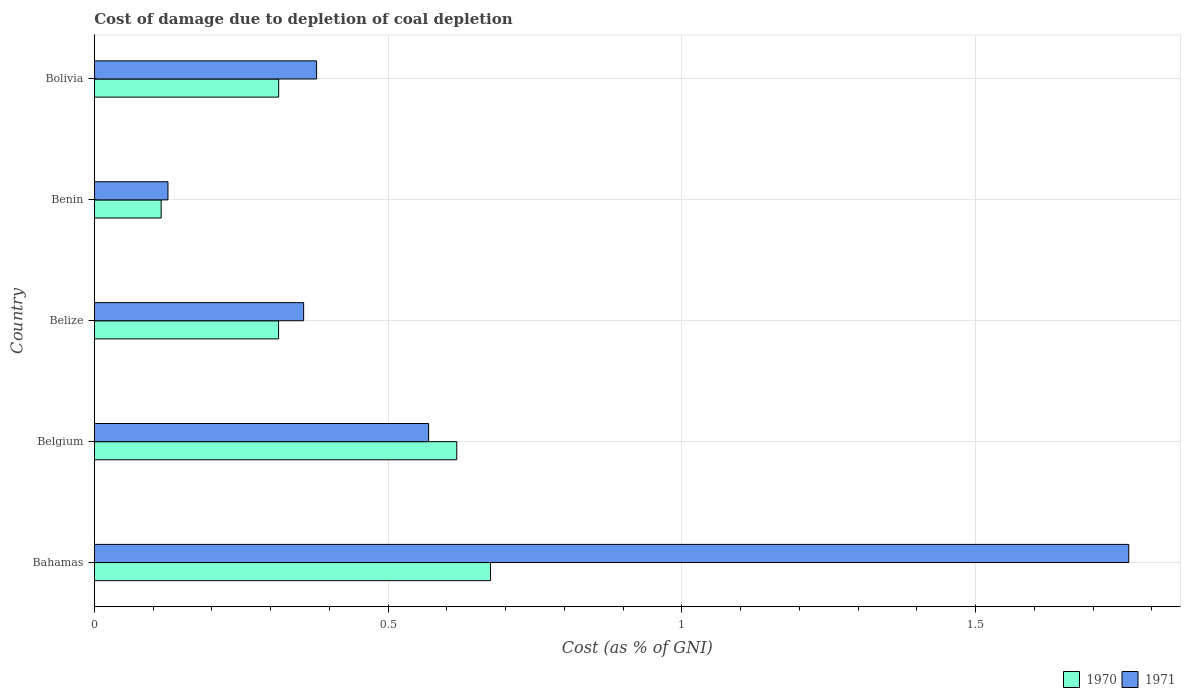How many different coloured bars are there?
Make the answer very short. 2. What is the label of the 5th group of bars from the top?
Make the answer very short. Bahamas. What is the cost of damage caused due to coal depletion in 1971 in Bahamas?
Provide a succinct answer. 1.76. Across all countries, what is the maximum cost of damage caused due to coal depletion in 1971?
Offer a terse response. 1.76. Across all countries, what is the minimum cost of damage caused due to coal depletion in 1971?
Give a very brief answer. 0.13. In which country was the cost of damage caused due to coal depletion in 1971 maximum?
Keep it short and to the point. Bahamas. In which country was the cost of damage caused due to coal depletion in 1971 minimum?
Provide a short and direct response. Benin. What is the total cost of damage caused due to coal depletion in 1971 in the graph?
Offer a very short reply. 3.19. What is the difference between the cost of damage caused due to coal depletion in 1971 in Belgium and that in Benin?
Offer a very short reply. 0.44. What is the difference between the cost of damage caused due to coal depletion in 1971 in Bahamas and the cost of damage caused due to coal depletion in 1970 in Bolivia?
Offer a terse response. 1.45. What is the average cost of damage caused due to coal depletion in 1971 per country?
Your answer should be very brief. 0.64. What is the difference between the cost of damage caused due to coal depletion in 1970 and cost of damage caused due to coal depletion in 1971 in Bahamas?
Keep it short and to the point. -1.09. What is the ratio of the cost of damage caused due to coal depletion in 1970 in Bahamas to that in Bolivia?
Your response must be concise. 2.15. Is the cost of damage caused due to coal depletion in 1970 in Bahamas less than that in Belgium?
Provide a succinct answer. No. What is the difference between the highest and the second highest cost of damage caused due to coal depletion in 1970?
Offer a very short reply. 0.06. What is the difference between the highest and the lowest cost of damage caused due to coal depletion in 1971?
Provide a short and direct response. 1.64. What does the 2nd bar from the top in Belize represents?
Provide a succinct answer. 1970. What does the 1st bar from the bottom in Belize represents?
Provide a short and direct response. 1970. How many bars are there?
Provide a short and direct response. 10. Does the graph contain any zero values?
Offer a terse response. No. Does the graph contain grids?
Offer a terse response. Yes. How many legend labels are there?
Ensure brevity in your answer.  2. What is the title of the graph?
Provide a succinct answer. Cost of damage due to depletion of coal depletion. Does "1960" appear as one of the legend labels in the graph?
Your answer should be very brief. No. What is the label or title of the X-axis?
Provide a short and direct response. Cost (as % of GNI). What is the label or title of the Y-axis?
Provide a succinct answer. Country. What is the Cost (as % of GNI) in 1970 in Bahamas?
Keep it short and to the point. 0.67. What is the Cost (as % of GNI) of 1971 in Bahamas?
Keep it short and to the point. 1.76. What is the Cost (as % of GNI) of 1970 in Belgium?
Your answer should be compact. 0.62. What is the Cost (as % of GNI) of 1971 in Belgium?
Your answer should be very brief. 0.57. What is the Cost (as % of GNI) in 1970 in Belize?
Your answer should be compact. 0.31. What is the Cost (as % of GNI) in 1971 in Belize?
Provide a short and direct response. 0.36. What is the Cost (as % of GNI) in 1970 in Benin?
Your answer should be very brief. 0.11. What is the Cost (as % of GNI) in 1971 in Benin?
Keep it short and to the point. 0.13. What is the Cost (as % of GNI) in 1970 in Bolivia?
Provide a succinct answer. 0.31. What is the Cost (as % of GNI) in 1971 in Bolivia?
Your answer should be very brief. 0.38. Across all countries, what is the maximum Cost (as % of GNI) in 1970?
Keep it short and to the point. 0.67. Across all countries, what is the maximum Cost (as % of GNI) in 1971?
Make the answer very short. 1.76. Across all countries, what is the minimum Cost (as % of GNI) of 1970?
Make the answer very short. 0.11. Across all countries, what is the minimum Cost (as % of GNI) in 1971?
Offer a terse response. 0.13. What is the total Cost (as % of GNI) of 1970 in the graph?
Make the answer very short. 2.03. What is the total Cost (as % of GNI) of 1971 in the graph?
Your response must be concise. 3.19. What is the difference between the Cost (as % of GNI) of 1970 in Bahamas and that in Belgium?
Provide a succinct answer. 0.06. What is the difference between the Cost (as % of GNI) of 1971 in Bahamas and that in Belgium?
Offer a terse response. 1.19. What is the difference between the Cost (as % of GNI) of 1970 in Bahamas and that in Belize?
Your answer should be very brief. 0.36. What is the difference between the Cost (as % of GNI) of 1971 in Bahamas and that in Belize?
Offer a terse response. 1.4. What is the difference between the Cost (as % of GNI) of 1970 in Bahamas and that in Benin?
Provide a short and direct response. 0.56. What is the difference between the Cost (as % of GNI) in 1971 in Bahamas and that in Benin?
Provide a short and direct response. 1.64. What is the difference between the Cost (as % of GNI) of 1970 in Bahamas and that in Bolivia?
Your answer should be compact. 0.36. What is the difference between the Cost (as % of GNI) in 1971 in Bahamas and that in Bolivia?
Provide a short and direct response. 1.38. What is the difference between the Cost (as % of GNI) of 1970 in Belgium and that in Belize?
Offer a terse response. 0.3. What is the difference between the Cost (as % of GNI) in 1971 in Belgium and that in Belize?
Your response must be concise. 0.21. What is the difference between the Cost (as % of GNI) of 1970 in Belgium and that in Benin?
Your answer should be compact. 0.5. What is the difference between the Cost (as % of GNI) of 1971 in Belgium and that in Benin?
Provide a short and direct response. 0.44. What is the difference between the Cost (as % of GNI) in 1970 in Belgium and that in Bolivia?
Keep it short and to the point. 0.3. What is the difference between the Cost (as % of GNI) in 1971 in Belgium and that in Bolivia?
Provide a short and direct response. 0.19. What is the difference between the Cost (as % of GNI) of 1970 in Belize and that in Benin?
Your response must be concise. 0.2. What is the difference between the Cost (as % of GNI) in 1971 in Belize and that in Benin?
Make the answer very short. 0.23. What is the difference between the Cost (as % of GNI) of 1970 in Belize and that in Bolivia?
Offer a terse response. -0. What is the difference between the Cost (as % of GNI) in 1971 in Belize and that in Bolivia?
Make the answer very short. -0.02. What is the difference between the Cost (as % of GNI) in 1971 in Benin and that in Bolivia?
Give a very brief answer. -0.25. What is the difference between the Cost (as % of GNI) of 1970 in Bahamas and the Cost (as % of GNI) of 1971 in Belgium?
Give a very brief answer. 0.11. What is the difference between the Cost (as % of GNI) in 1970 in Bahamas and the Cost (as % of GNI) in 1971 in Belize?
Your answer should be compact. 0.32. What is the difference between the Cost (as % of GNI) in 1970 in Bahamas and the Cost (as % of GNI) in 1971 in Benin?
Provide a short and direct response. 0.55. What is the difference between the Cost (as % of GNI) in 1970 in Bahamas and the Cost (as % of GNI) in 1971 in Bolivia?
Your answer should be very brief. 0.3. What is the difference between the Cost (as % of GNI) of 1970 in Belgium and the Cost (as % of GNI) of 1971 in Belize?
Your answer should be compact. 0.26. What is the difference between the Cost (as % of GNI) in 1970 in Belgium and the Cost (as % of GNI) in 1971 in Benin?
Your answer should be compact. 0.49. What is the difference between the Cost (as % of GNI) of 1970 in Belgium and the Cost (as % of GNI) of 1971 in Bolivia?
Provide a short and direct response. 0.24. What is the difference between the Cost (as % of GNI) in 1970 in Belize and the Cost (as % of GNI) in 1971 in Benin?
Provide a succinct answer. 0.19. What is the difference between the Cost (as % of GNI) in 1970 in Belize and the Cost (as % of GNI) in 1971 in Bolivia?
Your answer should be very brief. -0.06. What is the difference between the Cost (as % of GNI) in 1970 in Benin and the Cost (as % of GNI) in 1971 in Bolivia?
Your response must be concise. -0.26. What is the average Cost (as % of GNI) of 1970 per country?
Give a very brief answer. 0.41. What is the average Cost (as % of GNI) in 1971 per country?
Offer a terse response. 0.64. What is the difference between the Cost (as % of GNI) in 1970 and Cost (as % of GNI) in 1971 in Bahamas?
Your answer should be compact. -1.09. What is the difference between the Cost (as % of GNI) of 1970 and Cost (as % of GNI) of 1971 in Belgium?
Your response must be concise. 0.05. What is the difference between the Cost (as % of GNI) in 1970 and Cost (as % of GNI) in 1971 in Belize?
Give a very brief answer. -0.04. What is the difference between the Cost (as % of GNI) of 1970 and Cost (as % of GNI) of 1971 in Benin?
Your answer should be compact. -0.01. What is the difference between the Cost (as % of GNI) of 1970 and Cost (as % of GNI) of 1971 in Bolivia?
Provide a short and direct response. -0.06. What is the ratio of the Cost (as % of GNI) of 1970 in Bahamas to that in Belgium?
Provide a short and direct response. 1.09. What is the ratio of the Cost (as % of GNI) of 1971 in Bahamas to that in Belgium?
Provide a short and direct response. 3.09. What is the ratio of the Cost (as % of GNI) in 1970 in Bahamas to that in Belize?
Offer a very short reply. 2.15. What is the ratio of the Cost (as % of GNI) in 1971 in Bahamas to that in Belize?
Ensure brevity in your answer.  4.94. What is the ratio of the Cost (as % of GNI) of 1970 in Bahamas to that in Benin?
Make the answer very short. 5.93. What is the ratio of the Cost (as % of GNI) in 1971 in Bahamas to that in Benin?
Provide a short and direct response. 14.04. What is the ratio of the Cost (as % of GNI) of 1970 in Bahamas to that in Bolivia?
Ensure brevity in your answer.  2.15. What is the ratio of the Cost (as % of GNI) in 1971 in Bahamas to that in Bolivia?
Make the answer very short. 4.65. What is the ratio of the Cost (as % of GNI) in 1970 in Belgium to that in Belize?
Keep it short and to the point. 1.97. What is the ratio of the Cost (as % of GNI) in 1971 in Belgium to that in Belize?
Make the answer very short. 1.6. What is the ratio of the Cost (as % of GNI) in 1970 in Belgium to that in Benin?
Your answer should be very brief. 5.42. What is the ratio of the Cost (as % of GNI) of 1971 in Belgium to that in Benin?
Your answer should be compact. 4.54. What is the ratio of the Cost (as % of GNI) of 1970 in Belgium to that in Bolivia?
Give a very brief answer. 1.97. What is the ratio of the Cost (as % of GNI) in 1971 in Belgium to that in Bolivia?
Your answer should be very brief. 1.5. What is the ratio of the Cost (as % of GNI) in 1970 in Belize to that in Benin?
Offer a very short reply. 2.76. What is the ratio of the Cost (as % of GNI) of 1971 in Belize to that in Benin?
Your answer should be very brief. 2.84. What is the ratio of the Cost (as % of GNI) of 1970 in Belize to that in Bolivia?
Provide a succinct answer. 1. What is the ratio of the Cost (as % of GNI) of 1971 in Belize to that in Bolivia?
Your response must be concise. 0.94. What is the ratio of the Cost (as % of GNI) of 1970 in Benin to that in Bolivia?
Make the answer very short. 0.36. What is the ratio of the Cost (as % of GNI) of 1971 in Benin to that in Bolivia?
Provide a succinct answer. 0.33. What is the difference between the highest and the second highest Cost (as % of GNI) of 1970?
Offer a very short reply. 0.06. What is the difference between the highest and the second highest Cost (as % of GNI) of 1971?
Provide a short and direct response. 1.19. What is the difference between the highest and the lowest Cost (as % of GNI) in 1970?
Give a very brief answer. 0.56. What is the difference between the highest and the lowest Cost (as % of GNI) in 1971?
Your answer should be compact. 1.64. 